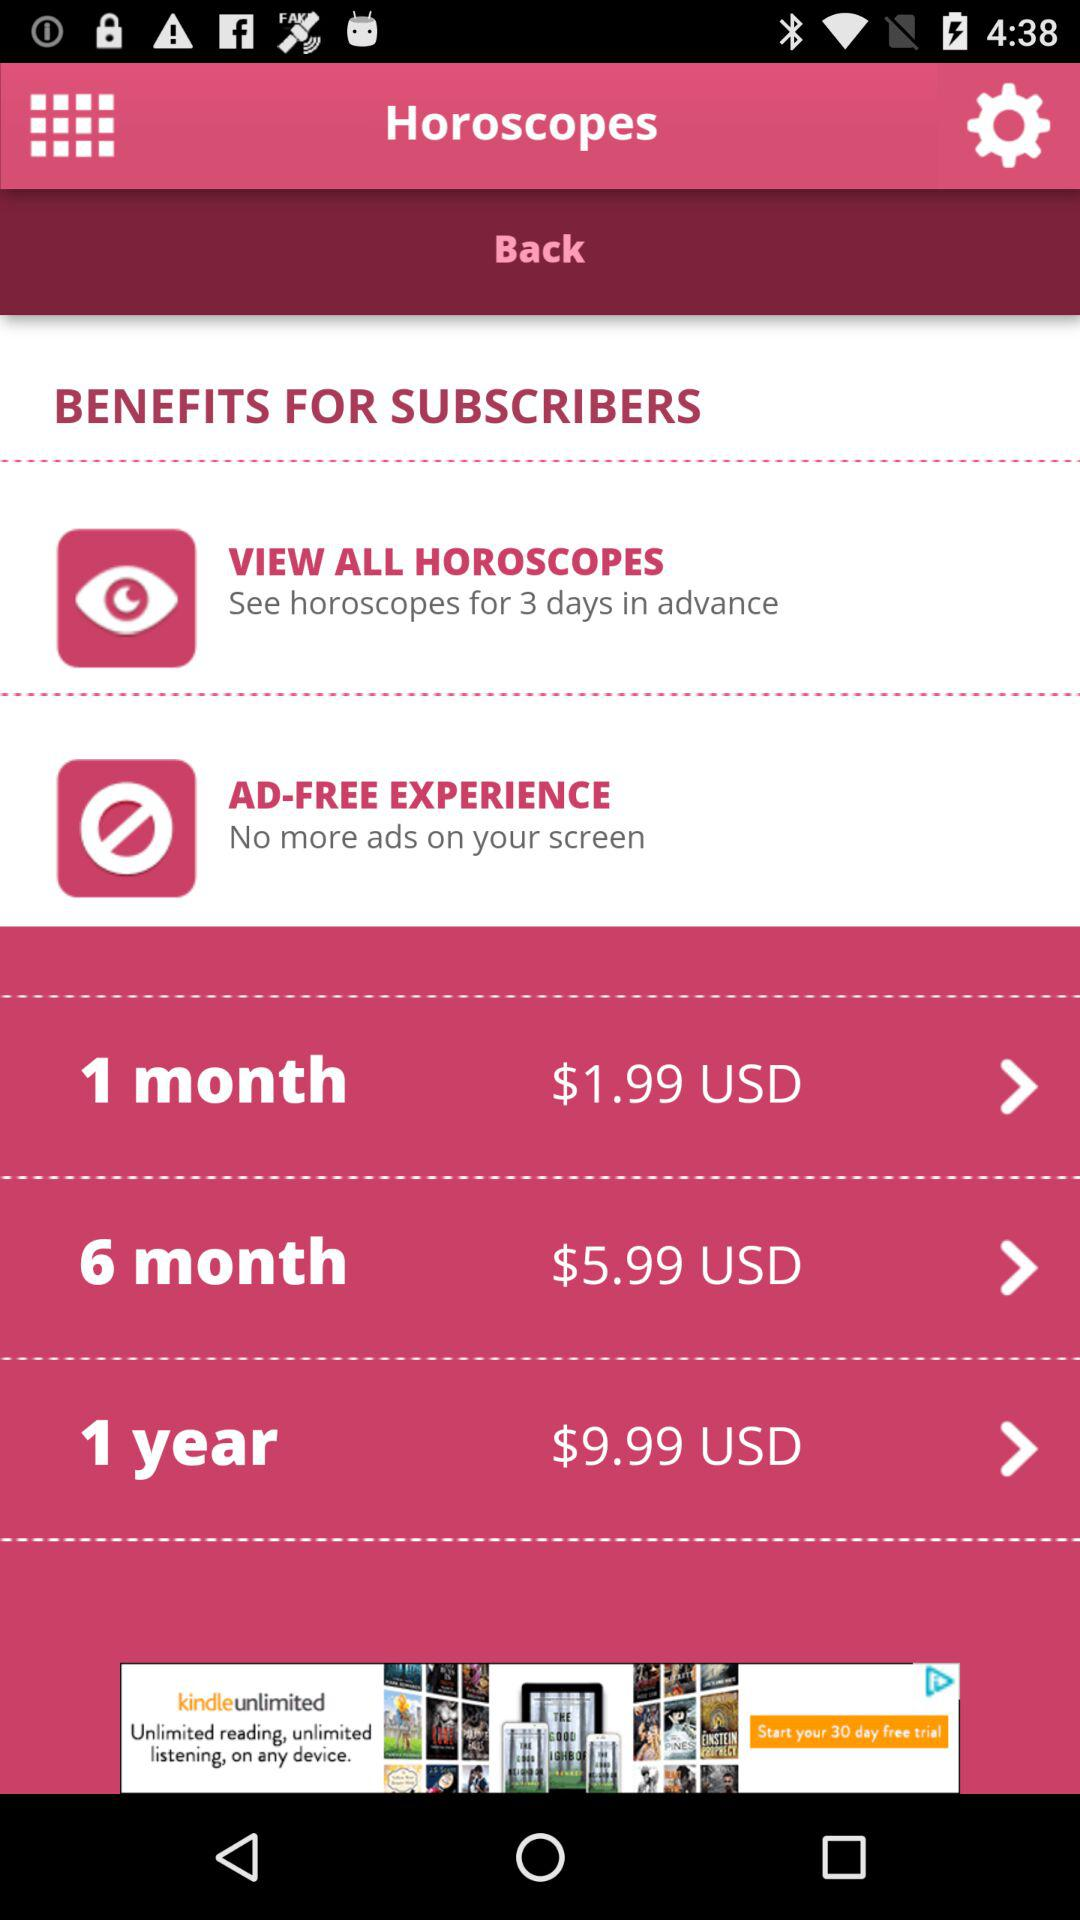What are the benefits for subscribers? The benefits are: view all horoscopes and ad-free experience. 